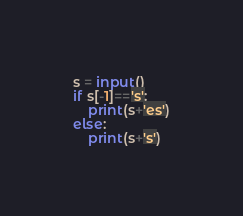Convert code to text. <code><loc_0><loc_0><loc_500><loc_500><_Python_>s = input()
if s[-1]=='s':
    print(s+'es')
else:
    print(s+'s')</code> 